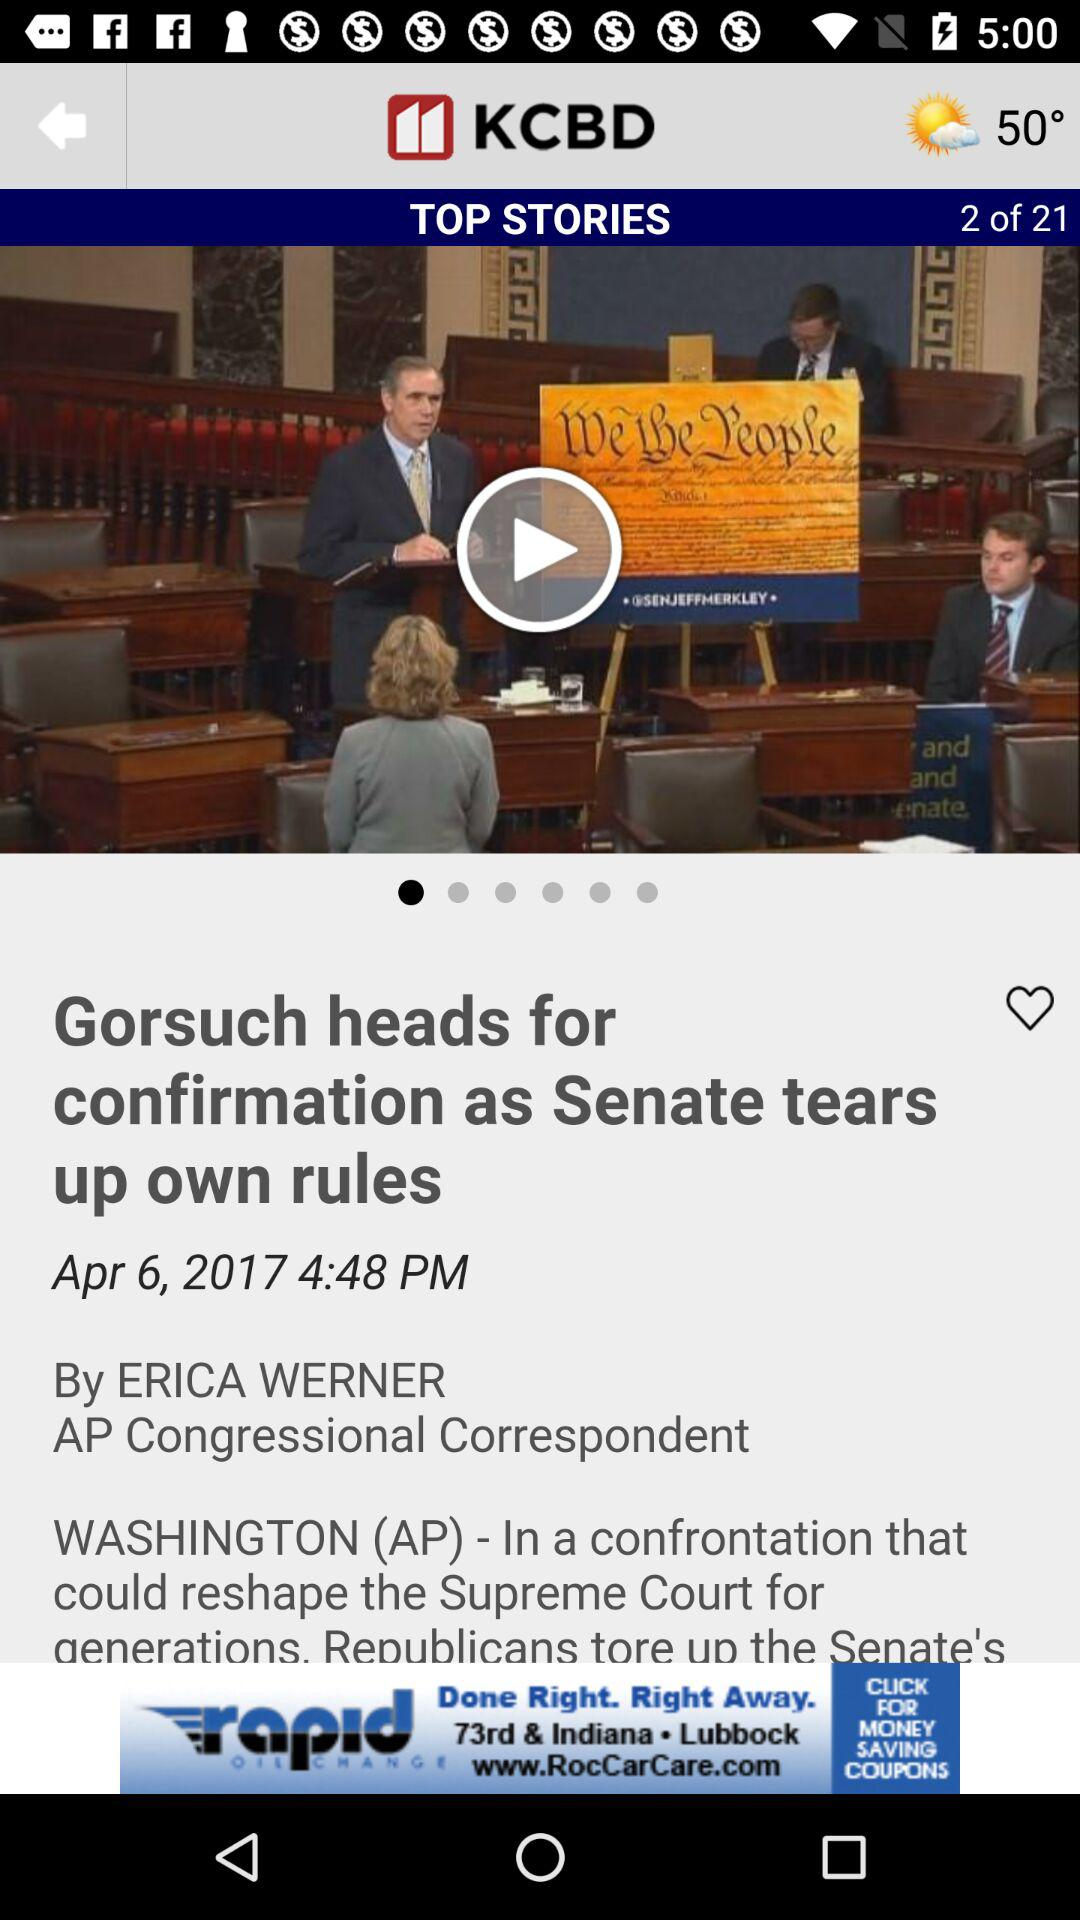What is the publication date? The publication date is April 6, 2017. 